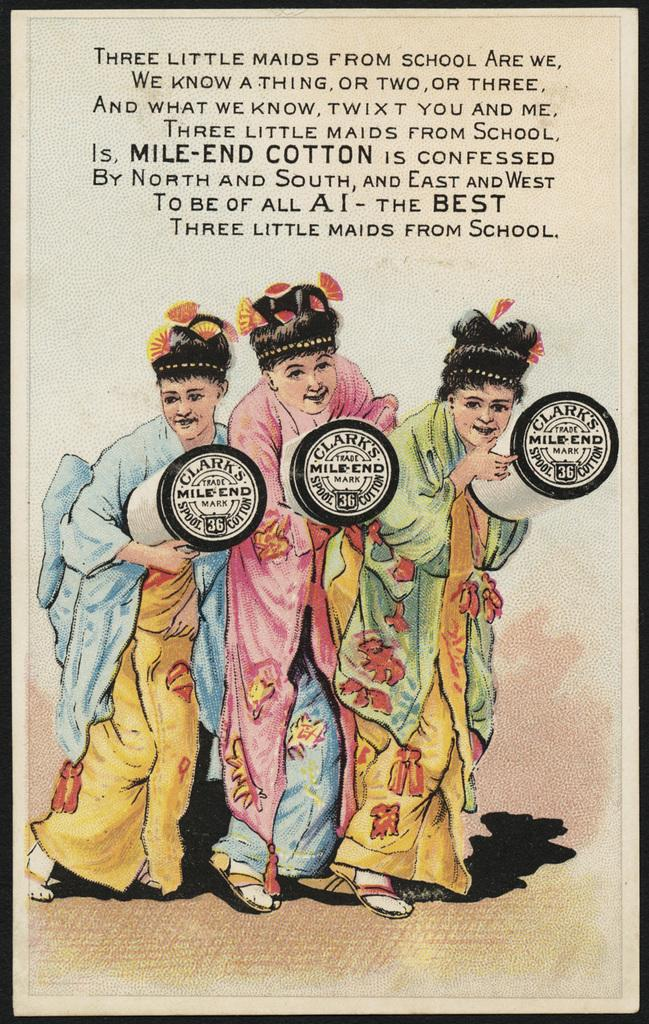What is present in the image that contains visual information? There is a poster in the image. What type of images can be seen on the poster? The poster contains images of humans. Is there any text present on the poster? Yes, there is text on the poster. What shape is the power source depicted in the image? There is no power source or shape mentioned in the image; it only contains a poster with images of humans and text. 